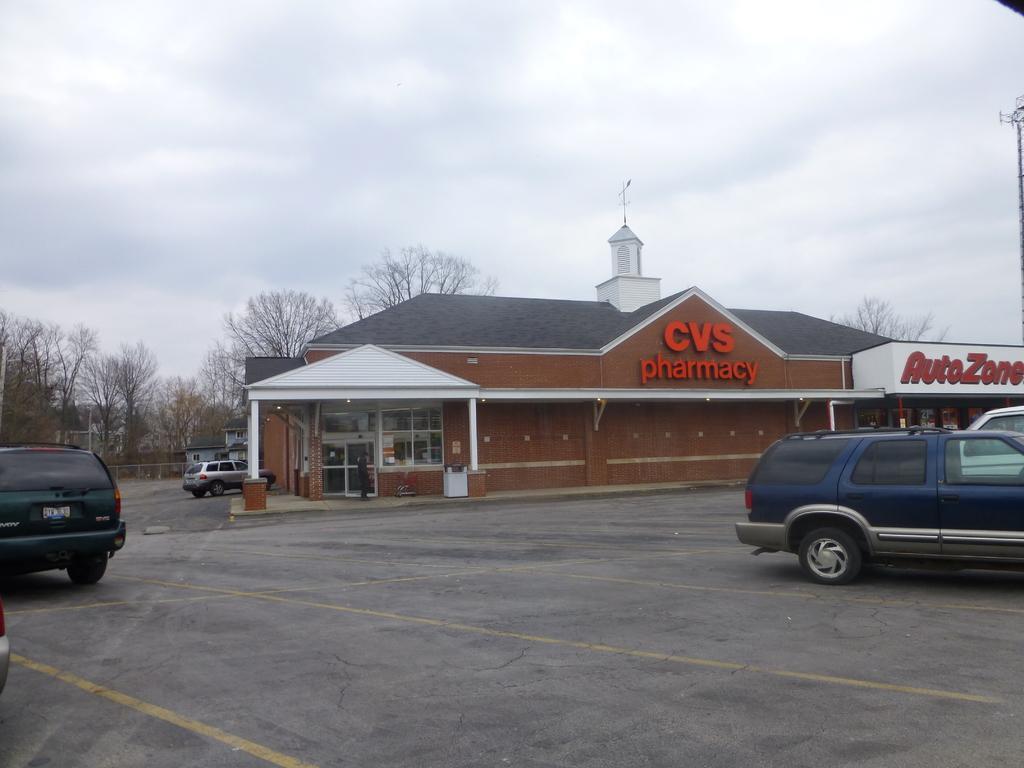Please provide a concise description of this image. In the picture I can see vehicles on the ground. In the background I can see a building, the sky and some other objects on the ground. 